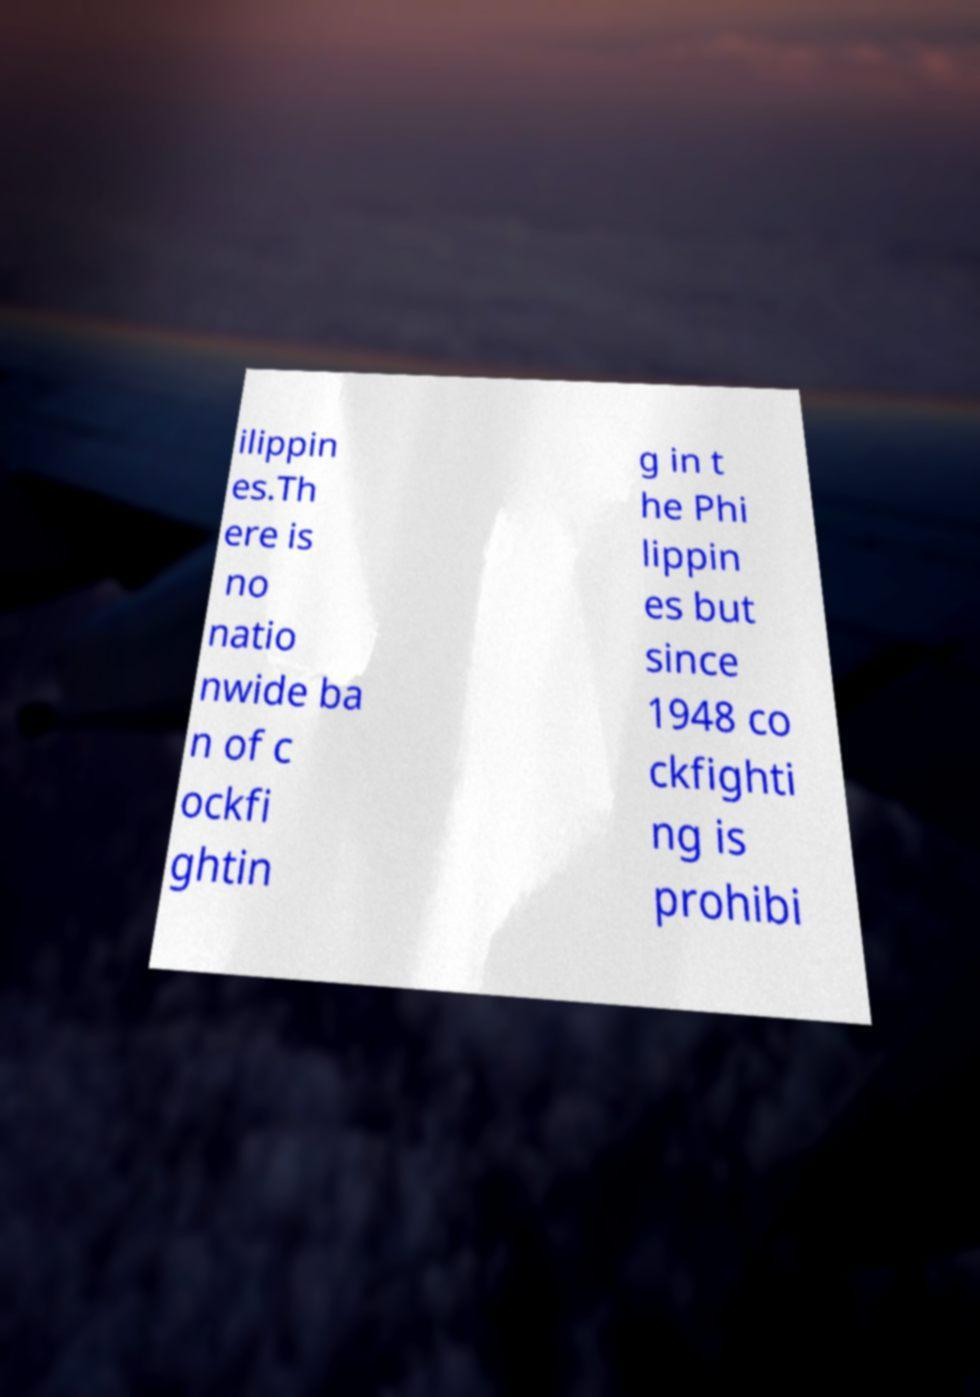There's text embedded in this image that I need extracted. Can you transcribe it verbatim? ilippin es.Th ere is no natio nwide ba n of c ockfi ghtin g in t he Phi lippin es but since 1948 co ckfighti ng is prohibi 